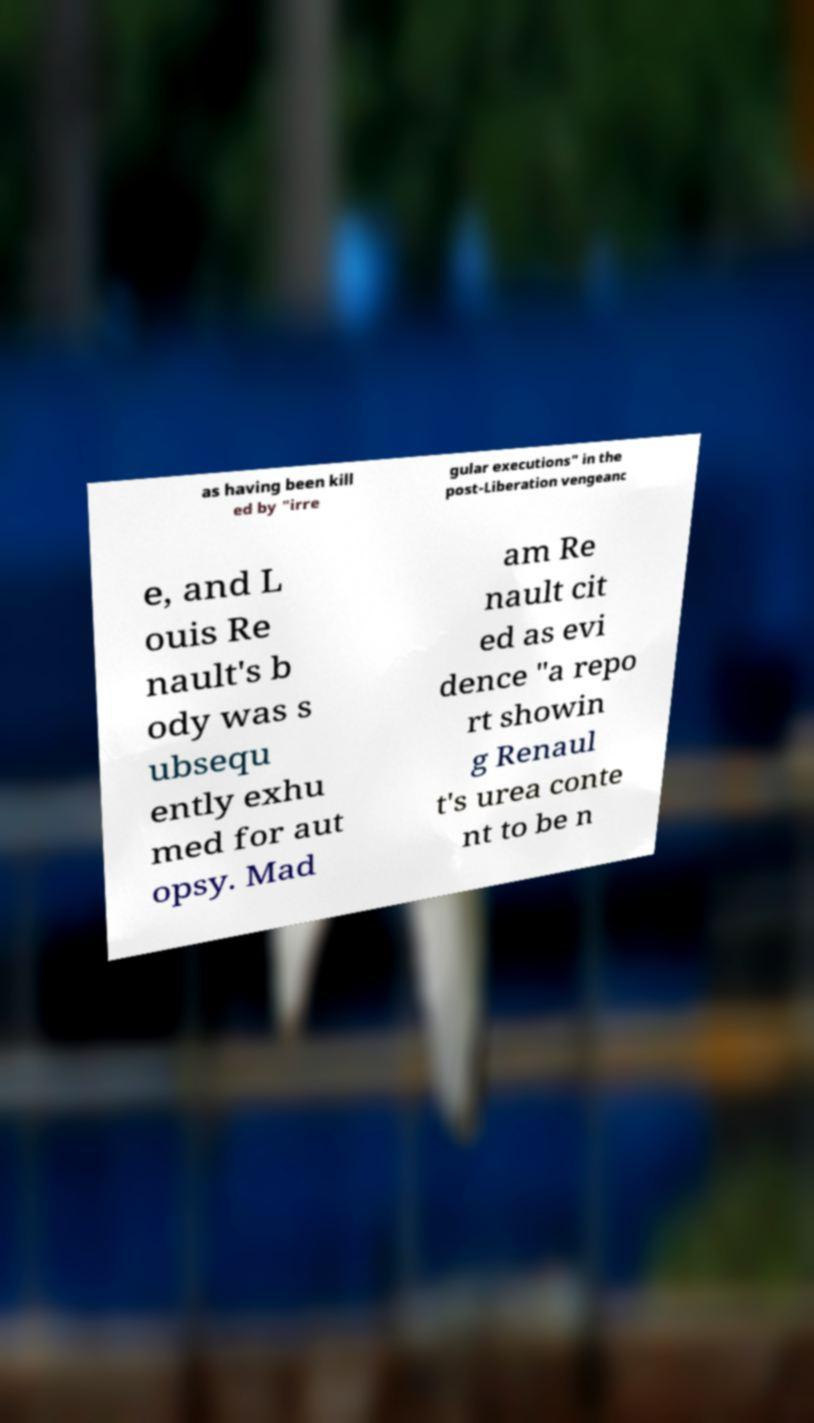Please identify and transcribe the text found in this image. as having been kill ed by "irre gular executions" in the post-Liberation vengeanc e, and L ouis Re nault's b ody was s ubsequ ently exhu med for aut opsy. Mad am Re nault cit ed as evi dence "a repo rt showin g Renaul t's urea conte nt to be n 